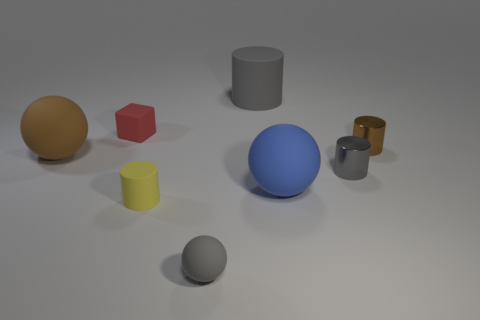Does the small shiny thing behind the big brown rubber thing have the same shape as the tiny gray thing that is behind the tiny yellow cylinder?
Your response must be concise. Yes. There is a tiny brown cylinder; how many big blue matte objects are behind it?
Provide a succinct answer. 0. Is the gray thing that is in front of the small yellow thing made of the same material as the small brown thing?
Provide a short and direct response. No. What is the color of the other big thing that is the same shape as the yellow thing?
Make the answer very short. Gray. The tiny brown metal object is what shape?
Offer a terse response. Cylinder. How many objects are either tiny gray cylinders or large rubber spheres?
Keep it short and to the point. 3. There is a thing behind the small red block; is it the same color as the shiny cylinder left of the tiny brown metallic cylinder?
Offer a terse response. Yes. What number of other objects are there of the same shape as the small gray shiny thing?
Your answer should be very brief. 3. Are any tiny yellow rubber cylinders visible?
Provide a succinct answer. Yes. What number of objects are either large gray rubber objects or metallic things that are in front of the tiny brown metal cylinder?
Ensure brevity in your answer.  2. 